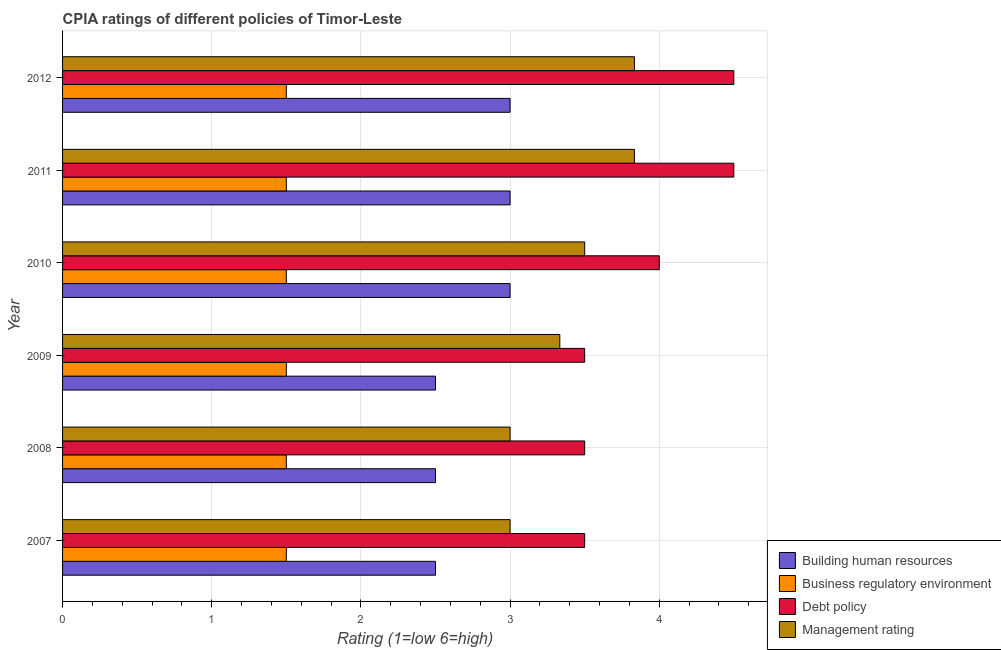How many groups of bars are there?
Provide a short and direct response. 6. Are the number of bars per tick equal to the number of legend labels?
Your response must be concise. Yes. How many bars are there on the 4th tick from the top?
Your answer should be very brief. 4. What is the cpia rating of debt policy in 2010?
Keep it short and to the point. 4. Across all years, what is the minimum cpia rating of building human resources?
Provide a succinct answer. 2.5. What is the total cpia rating of business regulatory environment in the graph?
Your answer should be compact. 9. What is the difference between the cpia rating of debt policy in 2008 and the cpia rating of management in 2012?
Offer a terse response. -0.33. What is the average cpia rating of debt policy per year?
Offer a very short reply. 3.92. In how many years, is the cpia rating of management greater than 2.2 ?
Your answer should be very brief. 6. What is the ratio of the cpia rating of building human resources in 2008 to that in 2012?
Provide a succinct answer. 0.83. Is the difference between the cpia rating of business regulatory environment in 2007 and 2012 greater than the difference between the cpia rating of management in 2007 and 2012?
Your response must be concise. Yes. What is the difference between the highest and the lowest cpia rating of building human resources?
Keep it short and to the point. 0.5. Is the sum of the cpia rating of building human resources in 2008 and 2010 greater than the maximum cpia rating of management across all years?
Make the answer very short. Yes. Is it the case that in every year, the sum of the cpia rating of business regulatory environment and cpia rating of building human resources is greater than the sum of cpia rating of debt policy and cpia rating of management?
Provide a succinct answer. No. What does the 1st bar from the top in 2008 represents?
Give a very brief answer. Management rating. What does the 2nd bar from the bottom in 2012 represents?
Give a very brief answer. Business regulatory environment. Is it the case that in every year, the sum of the cpia rating of building human resources and cpia rating of business regulatory environment is greater than the cpia rating of debt policy?
Provide a succinct answer. No. How many years are there in the graph?
Ensure brevity in your answer.  6. What is the difference between two consecutive major ticks on the X-axis?
Offer a terse response. 1. Are the values on the major ticks of X-axis written in scientific E-notation?
Provide a short and direct response. No. What is the title of the graph?
Give a very brief answer. CPIA ratings of different policies of Timor-Leste. Does "International Monetary Fund" appear as one of the legend labels in the graph?
Your answer should be very brief. No. What is the Rating (1=low 6=high) of Building human resources in 2007?
Ensure brevity in your answer.  2.5. What is the Rating (1=low 6=high) of Business regulatory environment in 2007?
Offer a very short reply. 1.5. What is the Rating (1=low 6=high) of Management rating in 2007?
Your response must be concise. 3. What is the Rating (1=low 6=high) of Business regulatory environment in 2008?
Ensure brevity in your answer.  1.5. What is the Rating (1=low 6=high) of Management rating in 2008?
Your answer should be very brief. 3. What is the Rating (1=low 6=high) in Building human resources in 2009?
Provide a short and direct response. 2.5. What is the Rating (1=low 6=high) in Debt policy in 2009?
Your response must be concise. 3.5. What is the Rating (1=low 6=high) of Management rating in 2009?
Make the answer very short. 3.33. What is the Rating (1=low 6=high) in Business regulatory environment in 2010?
Your response must be concise. 1.5. What is the Rating (1=low 6=high) in Debt policy in 2010?
Offer a terse response. 4. What is the Rating (1=low 6=high) in Building human resources in 2011?
Give a very brief answer. 3. What is the Rating (1=low 6=high) of Debt policy in 2011?
Your response must be concise. 4.5. What is the Rating (1=low 6=high) of Management rating in 2011?
Make the answer very short. 3.83. What is the Rating (1=low 6=high) in Business regulatory environment in 2012?
Offer a very short reply. 1.5. What is the Rating (1=low 6=high) of Management rating in 2012?
Ensure brevity in your answer.  3.83. Across all years, what is the maximum Rating (1=low 6=high) in Building human resources?
Your response must be concise. 3. Across all years, what is the maximum Rating (1=low 6=high) of Business regulatory environment?
Give a very brief answer. 1.5. Across all years, what is the maximum Rating (1=low 6=high) in Debt policy?
Offer a very short reply. 4.5. Across all years, what is the maximum Rating (1=low 6=high) of Management rating?
Make the answer very short. 3.83. Across all years, what is the minimum Rating (1=low 6=high) of Building human resources?
Your answer should be compact. 2.5. What is the total Rating (1=low 6=high) in Management rating in the graph?
Ensure brevity in your answer.  20.5. What is the difference between the Rating (1=low 6=high) in Management rating in 2007 and that in 2008?
Make the answer very short. 0. What is the difference between the Rating (1=low 6=high) of Debt policy in 2007 and that in 2009?
Offer a very short reply. 0. What is the difference between the Rating (1=low 6=high) of Management rating in 2007 and that in 2009?
Make the answer very short. -0.33. What is the difference between the Rating (1=low 6=high) in Business regulatory environment in 2007 and that in 2010?
Your answer should be very brief. 0. What is the difference between the Rating (1=low 6=high) of Debt policy in 2007 and that in 2010?
Provide a short and direct response. -0.5. What is the difference between the Rating (1=low 6=high) in Management rating in 2007 and that in 2010?
Your answer should be very brief. -0.5. What is the difference between the Rating (1=low 6=high) of Building human resources in 2007 and that in 2011?
Ensure brevity in your answer.  -0.5. What is the difference between the Rating (1=low 6=high) in Business regulatory environment in 2007 and that in 2011?
Offer a terse response. 0. What is the difference between the Rating (1=low 6=high) of Debt policy in 2007 and that in 2011?
Offer a very short reply. -1. What is the difference between the Rating (1=low 6=high) in Debt policy in 2007 and that in 2012?
Your answer should be very brief. -1. What is the difference between the Rating (1=low 6=high) in Management rating in 2007 and that in 2012?
Give a very brief answer. -0.83. What is the difference between the Rating (1=low 6=high) in Building human resources in 2008 and that in 2009?
Offer a terse response. 0. What is the difference between the Rating (1=low 6=high) in Management rating in 2008 and that in 2009?
Give a very brief answer. -0.33. What is the difference between the Rating (1=low 6=high) of Building human resources in 2008 and that in 2010?
Your answer should be compact. -0.5. What is the difference between the Rating (1=low 6=high) of Business regulatory environment in 2008 and that in 2010?
Give a very brief answer. 0. What is the difference between the Rating (1=low 6=high) of Business regulatory environment in 2008 and that in 2011?
Keep it short and to the point. 0. What is the difference between the Rating (1=low 6=high) in Management rating in 2008 and that in 2011?
Your answer should be compact. -0.83. What is the difference between the Rating (1=low 6=high) in Building human resources in 2008 and that in 2012?
Provide a succinct answer. -0.5. What is the difference between the Rating (1=low 6=high) of Management rating in 2008 and that in 2012?
Provide a succinct answer. -0.83. What is the difference between the Rating (1=low 6=high) of Business regulatory environment in 2009 and that in 2010?
Your answer should be compact. 0. What is the difference between the Rating (1=low 6=high) in Debt policy in 2009 and that in 2010?
Provide a short and direct response. -0.5. What is the difference between the Rating (1=low 6=high) of Debt policy in 2009 and that in 2011?
Offer a terse response. -1. What is the difference between the Rating (1=low 6=high) of Business regulatory environment in 2009 and that in 2012?
Your answer should be compact. 0. What is the difference between the Rating (1=low 6=high) of Management rating in 2009 and that in 2012?
Your answer should be very brief. -0.5. What is the difference between the Rating (1=low 6=high) in Building human resources in 2010 and that in 2011?
Offer a terse response. 0. What is the difference between the Rating (1=low 6=high) of Management rating in 2010 and that in 2011?
Provide a succinct answer. -0.33. What is the difference between the Rating (1=low 6=high) of Business regulatory environment in 2010 and that in 2012?
Your answer should be compact. 0. What is the difference between the Rating (1=low 6=high) of Debt policy in 2010 and that in 2012?
Provide a succinct answer. -0.5. What is the difference between the Rating (1=low 6=high) in Business regulatory environment in 2011 and that in 2012?
Ensure brevity in your answer.  0. What is the difference between the Rating (1=low 6=high) in Building human resources in 2007 and the Rating (1=low 6=high) in Business regulatory environment in 2009?
Your answer should be compact. 1. What is the difference between the Rating (1=low 6=high) of Business regulatory environment in 2007 and the Rating (1=low 6=high) of Management rating in 2009?
Keep it short and to the point. -1.83. What is the difference between the Rating (1=low 6=high) of Debt policy in 2007 and the Rating (1=low 6=high) of Management rating in 2009?
Your response must be concise. 0.17. What is the difference between the Rating (1=low 6=high) of Building human resources in 2007 and the Rating (1=low 6=high) of Debt policy in 2010?
Keep it short and to the point. -1.5. What is the difference between the Rating (1=low 6=high) in Building human resources in 2007 and the Rating (1=low 6=high) in Management rating in 2010?
Ensure brevity in your answer.  -1. What is the difference between the Rating (1=low 6=high) of Business regulatory environment in 2007 and the Rating (1=low 6=high) of Management rating in 2010?
Give a very brief answer. -2. What is the difference between the Rating (1=low 6=high) of Debt policy in 2007 and the Rating (1=low 6=high) of Management rating in 2010?
Ensure brevity in your answer.  0. What is the difference between the Rating (1=low 6=high) in Building human resources in 2007 and the Rating (1=low 6=high) in Business regulatory environment in 2011?
Keep it short and to the point. 1. What is the difference between the Rating (1=low 6=high) in Building human resources in 2007 and the Rating (1=low 6=high) in Management rating in 2011?
Ensure brevity in your answer.  -1.33. What is the difference between the Rating (1=low 6=high) in Business regulatory environment in 2007 and the Rating (1=low 6=high) in Debt policy in 2011?
Provide a short and direct response. -3. What is the difference between the Rating (1=low 6=high) in Business regulatory environment in 2007 and the Rating (1=low 6=high) in Management rating in 2011?
Keep it short and to the point. -2.33. What is the difference between the Rating (1=low 6=high) in Debt policy in 2007 and the Rating (1=low 6=high) in Management rating in 2011?
Keep it short and to the point. -0.33. What is the difference between the Rating (1=low 6=high) of Building human resources in 2007 and the Rating (1=low 6=high) of Debt policy in 2012?
Your answer should be very brief. -2. What is the difference between the Rating (1=low 6=high) of Building human resources in 2007 and the Rating (1=low 6=high) of Management rating in 2012?
Offer a terse response. -1.33. What is the difference between the Rating (1=low 6=high) in Business regulatory environment in 2007 and the Rating (1=low 6=high) in Management rating in 2012?
Make the answer very short. -2.33. What is the difference between the Rating (1=low 6=high) in Building human resources in 2008 and the Rating (1=low 6=high) in Debt policy in 2009?
Your response must be concise. -1. What is the difference between the Rating (1=low 6=high) in Business regulatory environment in 2008 and the Rating (1=low 6=high) in Management rating in 2009?
Your response must be concise. -1.83. What is the difference between the Rating (1=low 6=high) of Building human resources in 2008 and the Rating (1=low 6=high) of Management rating in 2010?
Make the answer very short. -1. What is the difference between the Rating (1=low 6=high) of Business regulatory environment in 2008 and the Rating (1=low 6=high) of Debt policy in 2010?
Your answer should be very brief. -2.5. What is the difference between the Rating (1=low 6=high) in Business regulatory environment in 2008 and the Rating (1=low 6=high) in Management rating in 2010?
Your answer should be compact. -2. What is the difference between the Rating (1=low 6=high) of Building human resources in 2008 and the Rating (1=low 6=high) of Management rating in 2011?
Offer a terse response. -1.33. What is the difference between the Rating (1=low 6=high) of Business regulatory environment in 2008 and the Rating (1=low 6=high) of Debt policy in 2011?
Ensure brevity in your answer.  -3. What is the difference between the Rating (1=low 6=high) in Business regulatory environment in 2008 and the Rating (1=low 6=high) in Management rating in 2011?
Keep it short and to the point. -2.33. What is the difference between the Rating (1=low 6=high) of Building human resources in 2008 and the Rating (1=low 6=high) of Business regulatory environment in 2012?
Provide a short and direct response. 1. What is the difference between the Rating (1=low 6=high) in Building human resources in 2008 and the Rating (1=low 6=high) in Management rating in 2012?
Offer a very short reply. -1.33. What is the difference between the Rating (1=low 6=high) of Business regulatory environment in 2008 and the Rating (1=low 6=high) of Debt policy in 2012?
Provide a short and direct response. -3. What is the difference between the Rating (1=low 6=high) in Business regulatory environment in 2008 and the Rating (1=low 6=high) in Management rating in 2012?
Your answer should be very brief. -2.33. What is the difference between the Rating (1=low 6=high) in Building human resources in 2009 and the Rating (1=low 6=high) in Management rating in 2010?
Ensure brevity in your answer.  -1. What is the difference between the Rating (1=low 6=high) in Debt policy in 2009 and the Rating (1=low 6=high) in Management rating in 2010?
Your answer should be very brief. 0. What is the difference between the Rating (1=low 6=high) in Building human resources in 2009 and the Rating (1=low 6=high) in Management rating in 2011?
Ensure brevity in your answer.  -1.33. What is the difference between the Rating (1=low 6=high) in Business regulatory environment in 2009 and the Rating (1=low 6=high) in Debt policy in 2011?
Provide a succinct answer. -3. What is the difference between the Rating (1=low 6=high) of Business regulatory environment in 2009 and the Rating (1=low 6=high) of Management rating in 2011?
Your answer should be very brief. -2.33. What is the difference between the Rating (1=low 6=high) of Building human resources in 2009 and the Rating (1=low 6=high) of Business regulatory environment in 2012?
Your response must be concise. 1. What is the difference between the Rating (1=low 6=high) of Building human resources in 2009 and the Rating (1=low 6=high) of Debt policy in 2012?
Offer a terse response. -2. What is the difference between the Rating (1=low 6=high) in Building human resources in 2009 and the Rating (1=low 6=high) in Management rating in 2012?
Provide a short and direct response. -1.33. What is the difference between the Rating (1=low 6=high) of Business regulatory environment in 2009 and the Rating (1=low 6=high) of Debt policy in 2012?
Provide a short and direct response. -3. What is the difference between the Rating (1=low 6=high) in Business regulatory environment in 2009 and the Rating (1=low 6=high) in Management rating in 2012?
Offer a terse response. -2.33. What is the difference between the Rating (1=low 6=high) of Debt policy in 2009 and the Rating (1=low 6=high) of Management rating in 2012?
Provide a short and direct response. -0.33. What is the difference between the Rating (1=low 6=high) of Building human resources in 2010 and the Rating (1=low 6=high) of Business regulatory environment in 2011?
Your response must be concise. 1.5. What is the difference between the Rating (1=low 6=high) of Building human resources in 2010 and the Rating (1=low 6=high) of Debt policy in 2011?
Your answer should be compact. -1.5. What is the difference between the Rating (1=low 6=high) of Building human resources in 2010 and the Rating (1=low 6=high) of Management rating in 2011?
Your response must be concise. -0.83. What is the difference between the Rating (1=low 6=high) in Business regulatory environment in 2010 and the Rating (1=low 6=high) in Management rating in 2011?
Ensure brevity in your answer.  -2.33. What is the difference between the Rating (1=low 6=high) in Debt policy in 2010 and the Rating (1=low 6=high) in Management rating in 2011?
Your answer should be very brief. 0.17. What is the difference between the Rating (1=low 6=high) in Building human resources in 2010 and the Rating (1=low 6=high) in Business regulatory environment in 2012?
Your answer should be compact. 1.5. What is the difference between the Rating (1=low 6=high) in Building human resources in 2010 and the Rating (1=low 6=high) in Management rating in 2012?
Keep it short and to the point. -0.83. What is the difference between the Rating (1=low 6=high) in Business regulatory environment in 2010 and the Rating (1=low 6=high) in Management rating in 2012?
Offer a terse response. -2.33. What is the difference between the Rating (1=low 6=high) of Debt policy in 2010 and the Rating (1=low 6=high) of Management rating in 2012?
Offer a very short reply. 0.17. What is the difference between the Rating (1=low 6=high) in Building human resources in 2011 and the Rating (1=low 6=high) in Business regulatory environment in 2012?
Provide a short and direct response. 1.5. What is the difference between the Rating (1=low 6=high) of Building human resources in 2011 and the Rating (1=low 6=high) of Management rating in 2012?
Your response must be concise. -0.83. What is the difference between the Rating (1=low 6=high) of Business regulatory environment in 2011 and the Rating (1=low 6=high) of Debt policy in 2012?
Keep it short and to the point. -3. What is the difference between the Rating (1=low 6=high) of Business regulatory environment in 2011 and the Rating (1=low 6=high) of Management rating in 2012?
Your response must be concise. -2.33. What is the average Rating (1=low 6=high) in Building human resources per year?
Offer a very short reply. 2.75. What is the average Rating (1=low 6=high) in Debt policy per year?
Give a very brief answer. 3.92. What is the average Rating (1=low 6=high) of Management rating per year?
Make the answer very short. 3.42. In the year 2007, what is the difference between the Rating (1=low 6=high) of Building human resources and Rating (1=low 6=high) of Business regulatory environment?
Give a very brief answer. 1. In the year 2008, what is the difference between the Rating (1=low 6=high) of Business regulatory environment and Rating (1=low 6=high) of Management rating?
Your answer should be very brief. -1.5. In the year 2008, what is the difference between the Rating (1=low 6=high) in Debt policy and Rating (1=low 6=high) in Management rating?
Provide a short and direct response. 0.5. In the year 2009, what is the difference between the Rating (1=low 6=high) of Building human resources and Rating (1=low 6=high) of Debt policy?
Provide a short and direct response. -1. In the year 2009, what is the difference between the Rating (1=low 6=high) of Business regulatory environment and Rating (1=low 6=high) of Management rating?
Keep it short and to the point. -1.83. In the year 2009, what is the difference between the Rating (1=low 6=high) in Debt policy and Rating (1=low 6=high) in Management rating?
Offer a very short reply. 0.17. In the year 2010, what is the difference between the Rating (1=low 6=high) in Business regulatory environment and Rating (1=low 6=high) in Management rating?
Ensure brevity in your answer.  -2. In the year 2011, what is the difference between the Rating (1=low 6=high) of Building human resources and Rating (1=low 6=high) of Business regulatory environment?
Keep it short and to the point. 1.5. In the year 2011, what is the difference between the Rating (1=low 6=high) in Building human resources and Rating (1=low 6=high) in Debt policy?
Offer a very short reply. -1.5. In the year 2011, what is the difference between the Rating (1=low 6=high) of Business regulatory environment and Rating (1=low 6=high) of Debt policy?
Offer a terse response. -3. In the year 2011, what is the difference between the Rating (1=low 6=high) of Business regulatory environment and Rating (1=low 6=high) of Management rating?
Offer a very short reply. -2.33. In the year 2011, what is the difference between the Rating (1=low 6=high) of Debt policy and Rating (1=low 6=high) of Management rating?
Ensure brevity in your answer.  0.67. In the year 2012, what is the difference between the Rating (1=low 6=high) of Building human resources and Rating (1=low 6=high) of Business regulatory environment?
Make the answer very short. 1.5. In the year 2012, what is the difference between the Rating (1=low 6=high) in Business regulatory environment and Rating (1=low 6=high) in Debt policy?
Ensure brevity in your answer.  -3. In the year 2012, what is the difference between the Rating (1=low 6=high) of Business regulatory environment and Rating (1=low 6=high) of Management rating?
Your answer should be very brief. -2.33. What is the ratio of the Rating (1=low 6=high) of Building human resources in 2007 to that in 2008?
Make the answer very short. 1. What is the ratio of the Rating (1=low 6=high) in Debt policy in 2007 to that in 2008?
Give a very brief answer. 1. What is the ratio of the Rating (1=low 6=high) in Business regulatory environment in 2007 to that in 2009?
Offer a very short reply. 1. What is the ratio of the Rating (1=low 6=high) in Management rating in 2007 to that in 2009?
Your answer should be compact. 0.9. What is the ratio of the Rating (1=low 6=high) of Building human resources in 2007 to that in 2010?
Ensure brevity in your answer.  0.83. What is the ratio of the Rating (1=low 6=high) of Business regulatory environment in 2007 to that in 2010?
Offer a terse response. 1. What is the ratio of the Rating (1=low 6=high) of Management rating in 2007 to that in 2010?
Make the answer very short. 0.86. What is the ratio of the Rating (1=low 6=high) of Business regulatory environment in 2007 to that in 2011?
Your answer should be very brief. 1. What is the ratio of the Rating (1=low 6=high) of Debt policy in 2007 to that in 2011?
Provide a succinct answer. 0.78. What is the ratio of the Rating (1=low 6=high) in Management rating in 2007 to that in 2011?
Make the answer very short. 0.78. What is the ratio of the Rating (1=low 6=high) in Management rating in 2007 to that in 2012?
Offer a very short reply. 0.78. What is the ratio of the Rating (1=low 6=high) of Business regulatory environment in 2008 to that in 2009?
Offer a very short reply. 1. What is the ratio of the Rating (1=low 6=high) in Business regulatory environment in 2008 to that in 2010?
Provide a succinct answer. 1. What is the ratio of the Rating (1=low 6=high) in Building human resources in 2008 to that in 2011?
Your answer should be compact. 0.83. What is the ratio of the Rating (1=low 6=high) in Business regulatory environment in 2008 to that in 2011?
Offer a very short reply. 1. What is the ratio of the Rating (1=low 6=high) of Management rating in 2008 to that in 2011?
Your answer should be compact. 0.78. What is the ratio of the Rating (1=low 6=high) of Building human resources in 2008 to that in 2012?
Offer a terse response. 0.83. What is the ratio of the Rating (1=low 6=high) in Business regulatory environment in 2008 to that in 2012?
Make the answer very short. 1. What is the ratio of the Rating (1=low 6=high) in Management rating in 2008 to that in 2012?
Keep it short and to the point. 0.78. What is the ratio of the Rating (1=low 6=high) of Building human resources in 2009 to that in 2010?
Ensure brevity in your answer.  0.83. What is the ratio of the Rating (1=low 6=high) in Business regulatory environment in 2009 to that in 2010?
Provide a short and direct response. 1. What is the ratio of the Rating (1=low 6=high) of Debt policy in 2009 to that in 2010?
Your answer should be very brief. 0.88. What is the ratio of the Rating (1=low 6=high) in Management rating in 2009 to that in 2010?
Offer a terse response. 0.95. What is the ratio of the Rating (1=low 6=high) in Building human resources in 2009 to that in 2011?
Provide a succinct answer. 0.83. What is the ratio of the Rating (1=low 6=high) of Management rating in 2009 to that in 2011?
Make the answer very short. 0.87. What is the ratio of the Rating (1=low 6=high) of Business regulatory environment in 2009 to that in 2012?
Offer a very short reply. 1. What is the ratio of the Rating (1=low 6=high) in Debt policy in 2009 to that in 2012?
Make the answer very short. 0.78. What is the ratio of the Rating (1=low 6=high) of Management rating in 2009 to that in 2012?
Your answer should be compact. 0.87. What is the ratio of the Rating (1=low 6=high) of Building human resources in 2010 to that in 2011?
Give a very brief answer. 1. What is the ratio of the Rating (1=low 6=high) of Business regulatory environment in 2010 to that in 2011?
Give a very brief answer. 1. What is the ratio of the Rating (1=low 6=high) of Debt policy in 2010 to that in 2011?
Your answer should be compact. 0.89. What is the ratio of the Rating (1=low 6=high) in Building human resources in 2010 to that in 2012?
Make the answer very short. 1. What is the ratio of the Rating (1=low 6=high) in Building human resources in 2011 to that in 2012?
Give a very brief answer. 1. What is the difference between the highest and the second highest Rating (1=low 6=high) of Building human resources?
Ensure brevity in your answer.  0. What is the difference between the highest and the second highest Rating (1=low 6=high) in Business regulatory environment?
Offer a terse response. 0. What is the difference between the highest and the second highest Rating (1=low 6=high) of Debt policy?
Your answer should be compact. 0. What is the difference between the highest and the second highest Rating (1=low 6=high) in Management rating?
Your answer should be compact. 0. What is the difference between the highest and the lowest Rating (1=low 6=high) in Business regulatory environment?
Offer a very short reply. 0. What is the difference between the highest and the lowest Rating (1=low 6=high) of Debt policy?
Keep it short and to the point. 1. What is the difference between the highest and the lowest Rating (1=low 6=high) of Management rating?
Keep it short and to the point. 0.83. 